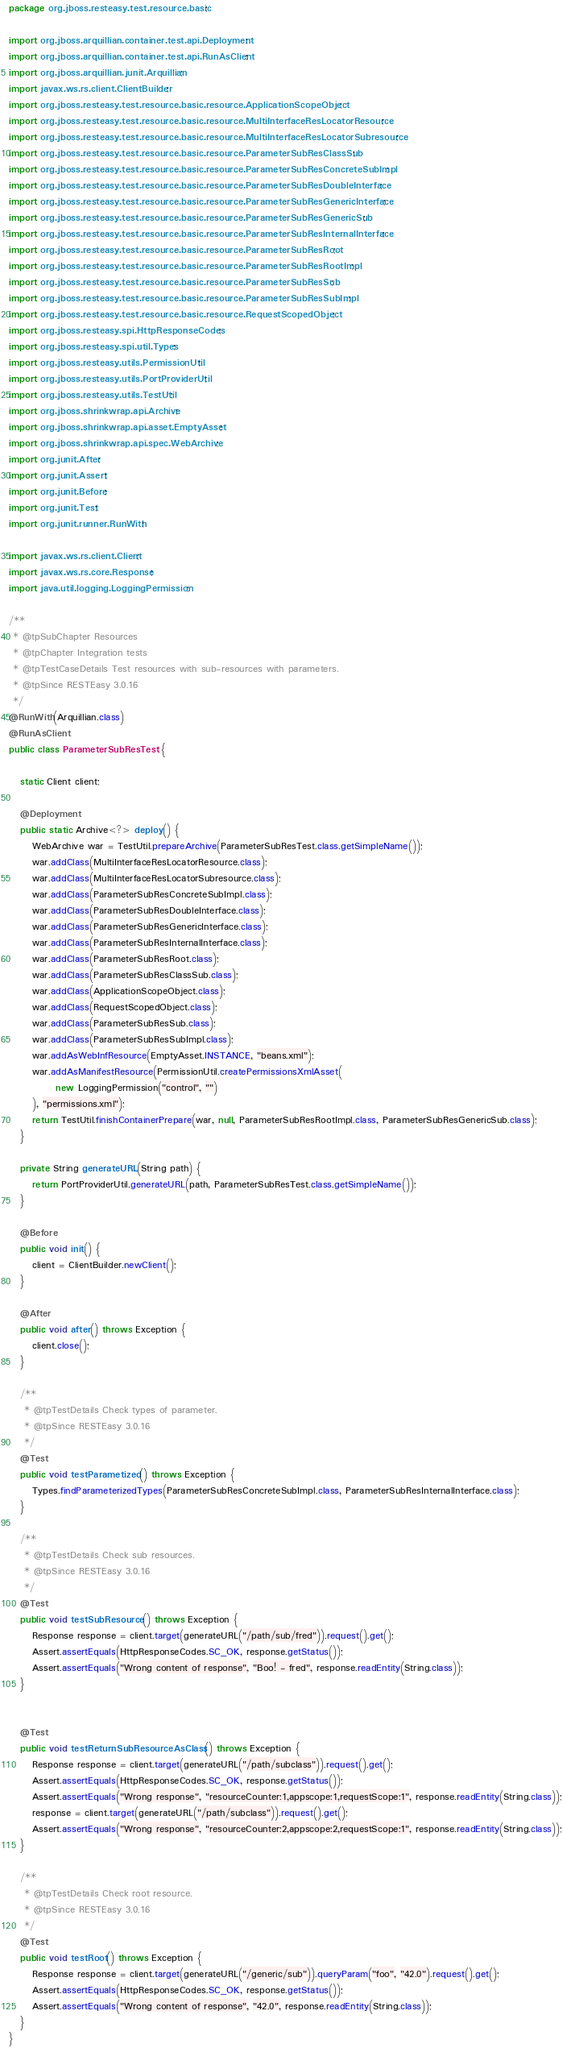<code> <loc_0><loc_0><loc_500><loc_500><_Java_>package org.jboss.resteasy.test.resource.basic;

import org.jboss.arquillian.container.test.api.Deployment;
import org.jboss.arquillian.container.test.api.RunAsClient;
import org.jboss.arquillian.junit.Arquillian;
import javax.ws.rs.client.ClientBuilder;
import org.jboss.resteasy.test.resource.basic.resource.ApplicationScopeObject;
import org.jboss.resteasy.test.resource.basic.resource.MultiInterfaceResLocatorResource;
import org.jboss.resteasy.test.resource.basic.resource.MultiInterfaceResLocatorSubresource;
import org.jboss.resteasy.test.resource.basic.resource.ParameterSubResClassSub;
import org.jboss.resteasy.test.resource.basic.resource.ParameterSubResConcreteSubImpl;
import org.jboss.resteasy.test.resource.basic.resource.ParameterSubResDoubleInterface;
import org.jboss.resteasy.test.resource.basic.resource.ParameterSubResGenericInterface;
import org.jboss.resteasy.test.resource.basic.resource.ParameterSubResGenericSub;
import org.jboss.resteasy.test.resource.basic.resource.ParameterSubResInternalInterface;
import org.jboss.resteasy.test.resource.basic.resource.ParameterSubResRoot;
import org.jboss.resteasy.test.resource.basic.resource.ParameterSubResRootImpl;
import org.jboss.resteasy.test.resource.basic.resource.ParameterSubResSub;
import org.jboss.resteasy.test.resource.basic.resource.ParameterSubResSubImpl;
import org.jboss.resteasy.test.resource.basic.resource.RequestScopedObject;
import org.jboss.resteasy.spi.HttpResponseCodes;
import org.jboss.resteasy.spi.util.Types;
import org.jboss.resteasy.utils.PermissionUtil;
import org.jboss.resteasy.utils.PortProviderUtil;
import org.jboss.resteasy.utils.TestUtil;
import org.jboss.shrinkwrap.api.Archive;
import org.jboss.shrinkwrap.api.asset.EmptyAsset;
import org.jboss.shrinkwrap.api.spec.WebArchive;
import org.junit.After;
import org.junit.Assert;
import org.junit.Before;
import org.junit.Test;
import org.junit.runner.RunWith;

import javax.ws.rs.client.Client;
import javax.ws.rs.core.Response;
import java.util.logging.LoggingPermission;

/**
 * @tpSubChapter Resources
 * @tpChapter Integration tests
 * @tpTestCaseDetails Test resources with sub-resources with parameters.
 * @tpSince RESTEasy 3.0.16
 */
@RunWith(Arquillian.class)
@RunAsClient
public class ParameterSubResTest {

   static Client client;

   @Deployment
   public static Archive<?> deploy() {
      WebArchive war = TestUtil.prepareArchive(ParameterSubResTest.class.getSimpleName());
      war.addClass(MultiInterfaceResLocatorResource.class);
      war.addClass(MultiInterfaceResLocatorSubresource.class);
      war.addClass(ParameterSubResConcreteSubImpl.class);
      war.addClass(ParameterSubResDoubleInterface.class);
      war.addClass(ParameterSubResGenericInterface.class);
      war.addClass(ParameterSubResInternalInterface.class);
      war.addClass(ParameterSubResRoot.class);
      war.addClass(ParameterSubResClassSub.class);
      war.addClass(ApplicationScopeObject.class);
      war.addClass(RequestScopedObject.class);
      war.addClass(ParameterSubResSub.class);
      war.addClass(ParameterSubResSubImpl.class);
      war.addAsWebInfResource(EmptyAsset.INSTANCE, "beans.xml");
      war.addAsManifestResource(PermissionUtil.createPermissionsXmlAsset(
            new LoggingPermission("control", "")
      ), "permissions.xml");
      return TestUtil.finishContainerPrepare(war, null, ParameterSubResRootImpl.class, ParameterSubResGenericSub.class);
   }

   private String generateURL(String path) {
      return PortProviderUtil.generateURL(path, ParameterSubResTest.class.getSimpleName());
   }

   @Before
   public void init() {
      client = ClientBuilder.newClient();
   }

   @After
   public void after() throws Exception {
      client.close();
   }

   /**
    * @tpTestDetails Check types of parameter.
    * @tpSince RESTEasy 3.0.16
    */
   @Test
   public void testParametized() throws Exception {
      Types.findParameterizedTypes(ParameterSubResConcreteSubImpl.class, ParameterSubResInternalInterface.class);
   }

   /**
    * @tpTestDetails Check sub resources.
    * @tpSince RESTEasy 3.0.16
    */
   @Test
   public void testSubResource() throws Exception {
      Response response = client.target(generateURL("/path/sub/fred")).request().get();
      Assert.assertEquals(HttpResponseCodes.SC_OK, response.getStatus());
      Assert.assertEquals("Wrong content of response", "Boo! - fred", response.readEntity(String.class));
   }


   @Test
   public void testReturnSubResourceAsClass() throws Exception {
      Response response = client.target(generateURL("/path/subclass")).request().get();
      Assert.assertEquals(HttpResponseCodes.SC_OK, response.getStatus());
      Assert.assertEquals("Wrong response", "resourceCounter:1,appscope:1,requestScope:1", response.readEntity(String.class));
      response = client.target(generateURL("/path/subclass")).request().get();
      Assert.assertEquals("Wrong response", "resourceCounter:2,appscope:2,requestScope:1", response.readEntity(String.class));
   }

   /**
    * @tpTestDetails Check root resource.
    * @tpSince RESTEasy 3.0.16
    */
   @Test
   public void testRoot() throws Exception {
      Response response = client.target(generateURL("/generic/sub")).queryParam("foo", "42.0").request().get();
      Assert.assertEquals(HttpResponseCodes.SC_OK, response.getStatus());
      Assert.assertEquals("Wrong content of response", "42.0", response.readEntity(String.class));
   }
}
</code> 